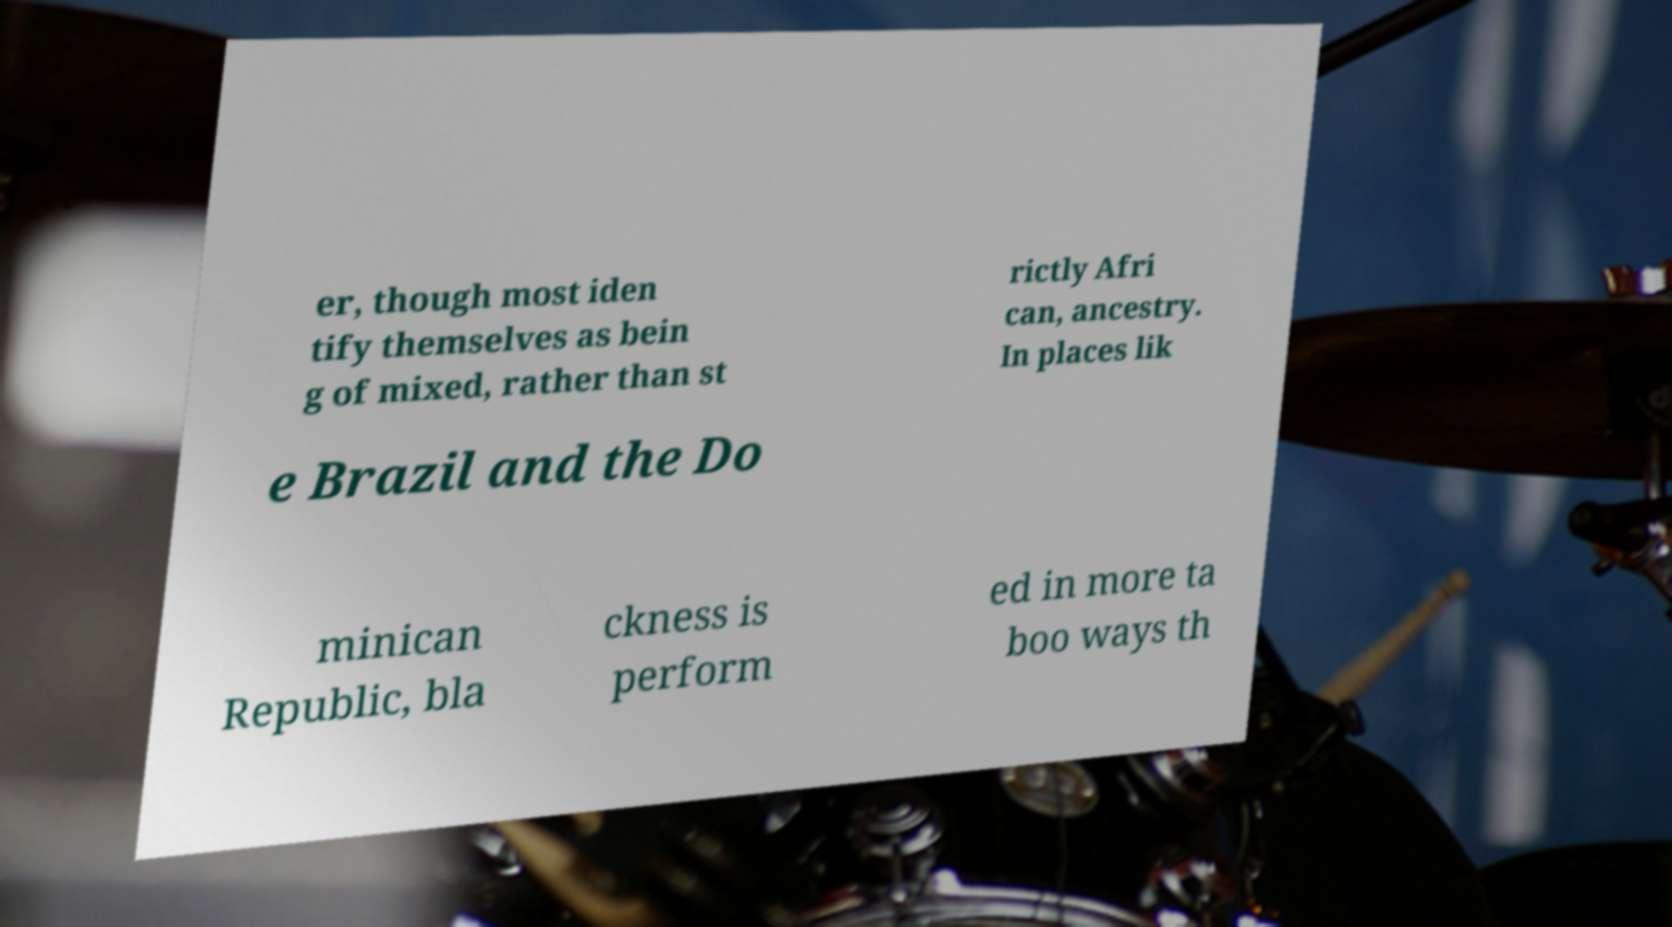Please read and relay the text visible in this image. What does it say? er, though most iden tify themselves as bein g of mixed, rather than st rictly Afri can, ancestry. In places lik e Brazil and the Do minican Republic, bla ckness is perform ed in more ta boo ways th 